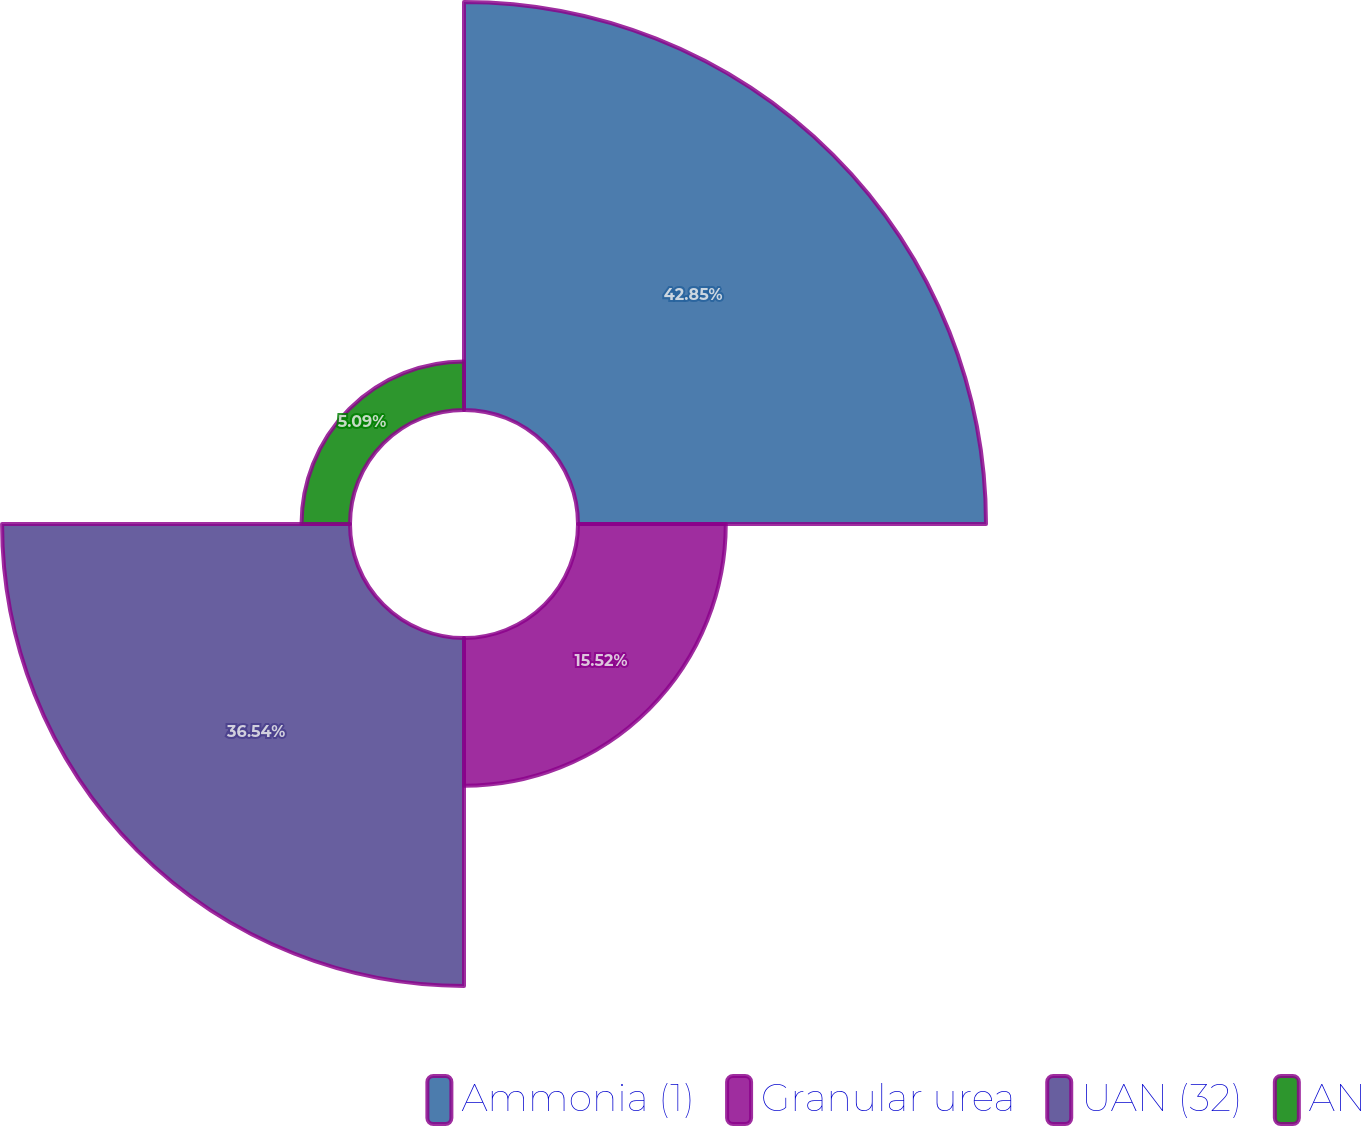<chart> <loc_0><loc_0><loc_500><loc_500><pie_chart><fcel>Ammonia (1)<fcel>Granular urea<fcel>UAN (32)<fcel>AN<nl><fcel>42.85%<fcel>15.52%<fcel>36.54%<fcel>5.09%<nl></chart> 